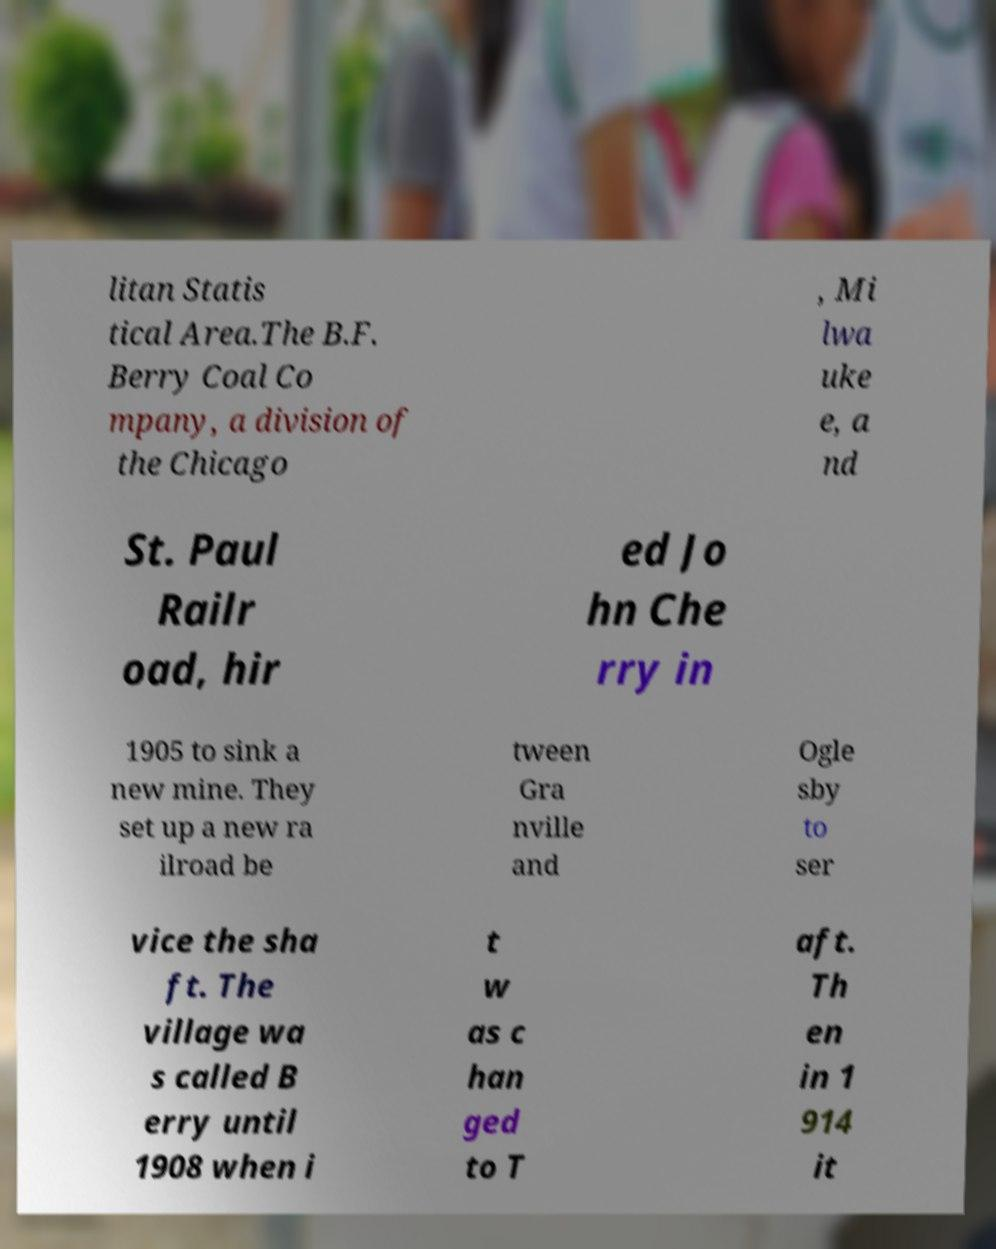For documentation purposes, I need the text within this image transcribed. Could you provide that? litan Statis tical Area.The B.F. Berry Coal Co mpany, a division of the Chicago , Mi lwa uke e, a nd St. Paul Railr oad, hir ed Jo hn Che rry in 1905 to sink a new mine. They set up a new ra ilroad be tween Gra nville and Ogle sby to ser vice the sha ft. The village wa s called B erry until 1908 when i t w as c han ged to T aft. Th en in 1 914 it 